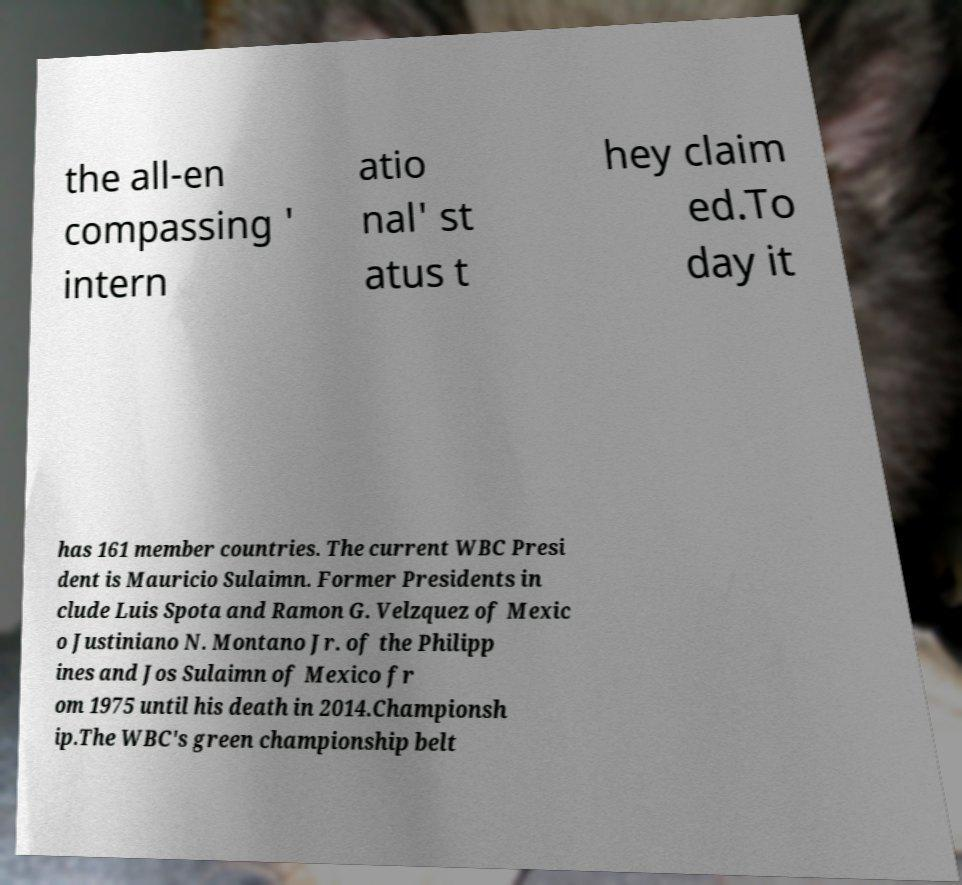Could you assist in decoding the text presented in this image and type it out clearly? the all-en compassing ' intern atio nal' st atus t hey claim ed.To day it has 161 member countries. The current WBC Presi dent is Mauricio Sulaimn. Former Presidents in clude Luis Spota and Ramon G. Velzquez of Mexic o Justiniano N. Montano Jr. of the Philipp ines and Jos Sulaimn of Mexico fr om 1975 until his death in 2014.Championsh ip.The WBC's green championship belt 